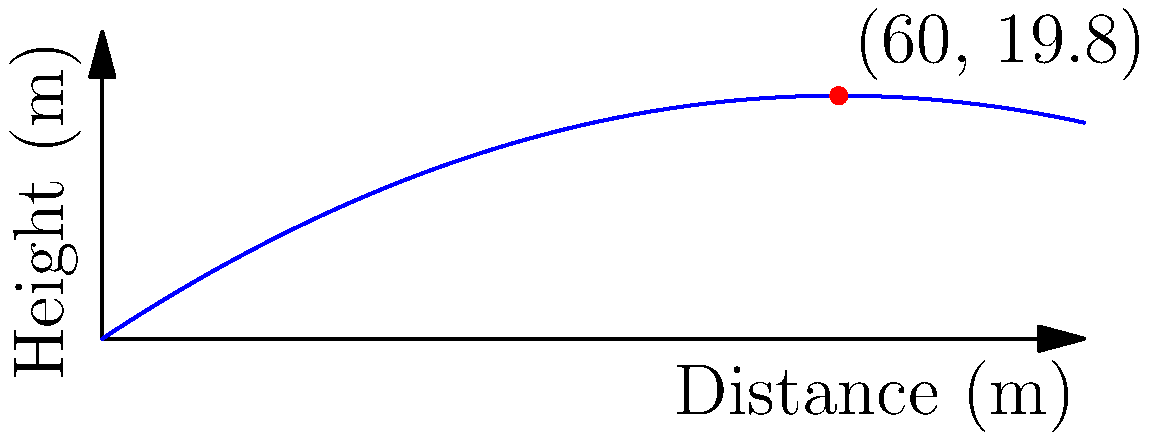The trajectory of a javelin throw can be modeled by the quadratic function $h(d) = -0.0055d^2 + 0.66d$, where $h$ is the height in meters and $d$ is the horizontal distance in meters. At what horizontal distance does the javelin reach its maximum height, and what is this maximum height? To find the maximum height and the corresponding horizontal distance, we need to follow these steps:

1) The maximum point of a parabola occurs at the vertex. For a quadratic function in the form $f(x) = ax^2 + bx + c$, the x-coordinate of the vertex is given by $x = -\frac{b}{2a}$.

2) In our case, $a = -0.0055$ and $b = 0.66$. Let's calculate the horizontal distance at the maximum point:

   $d = -\frac{0.66}{2(-0.0055)} = 60$ meters

3) To find the maximum height, we substitute this d-value into the original function:

   $h(60) = -0.0055(60)^2 + 0.66(60)$
          $= -0.0055(3600) + 39.6$
          $= -19.8 + 39.6$
          $= 19.8$ meters

Therefore, the javelin reaches its maximum height of 19.8 meters when it has traveled a horizontal distance of 60 meters.
Answer: Maximum height: 19.8 m at 60 m distance 